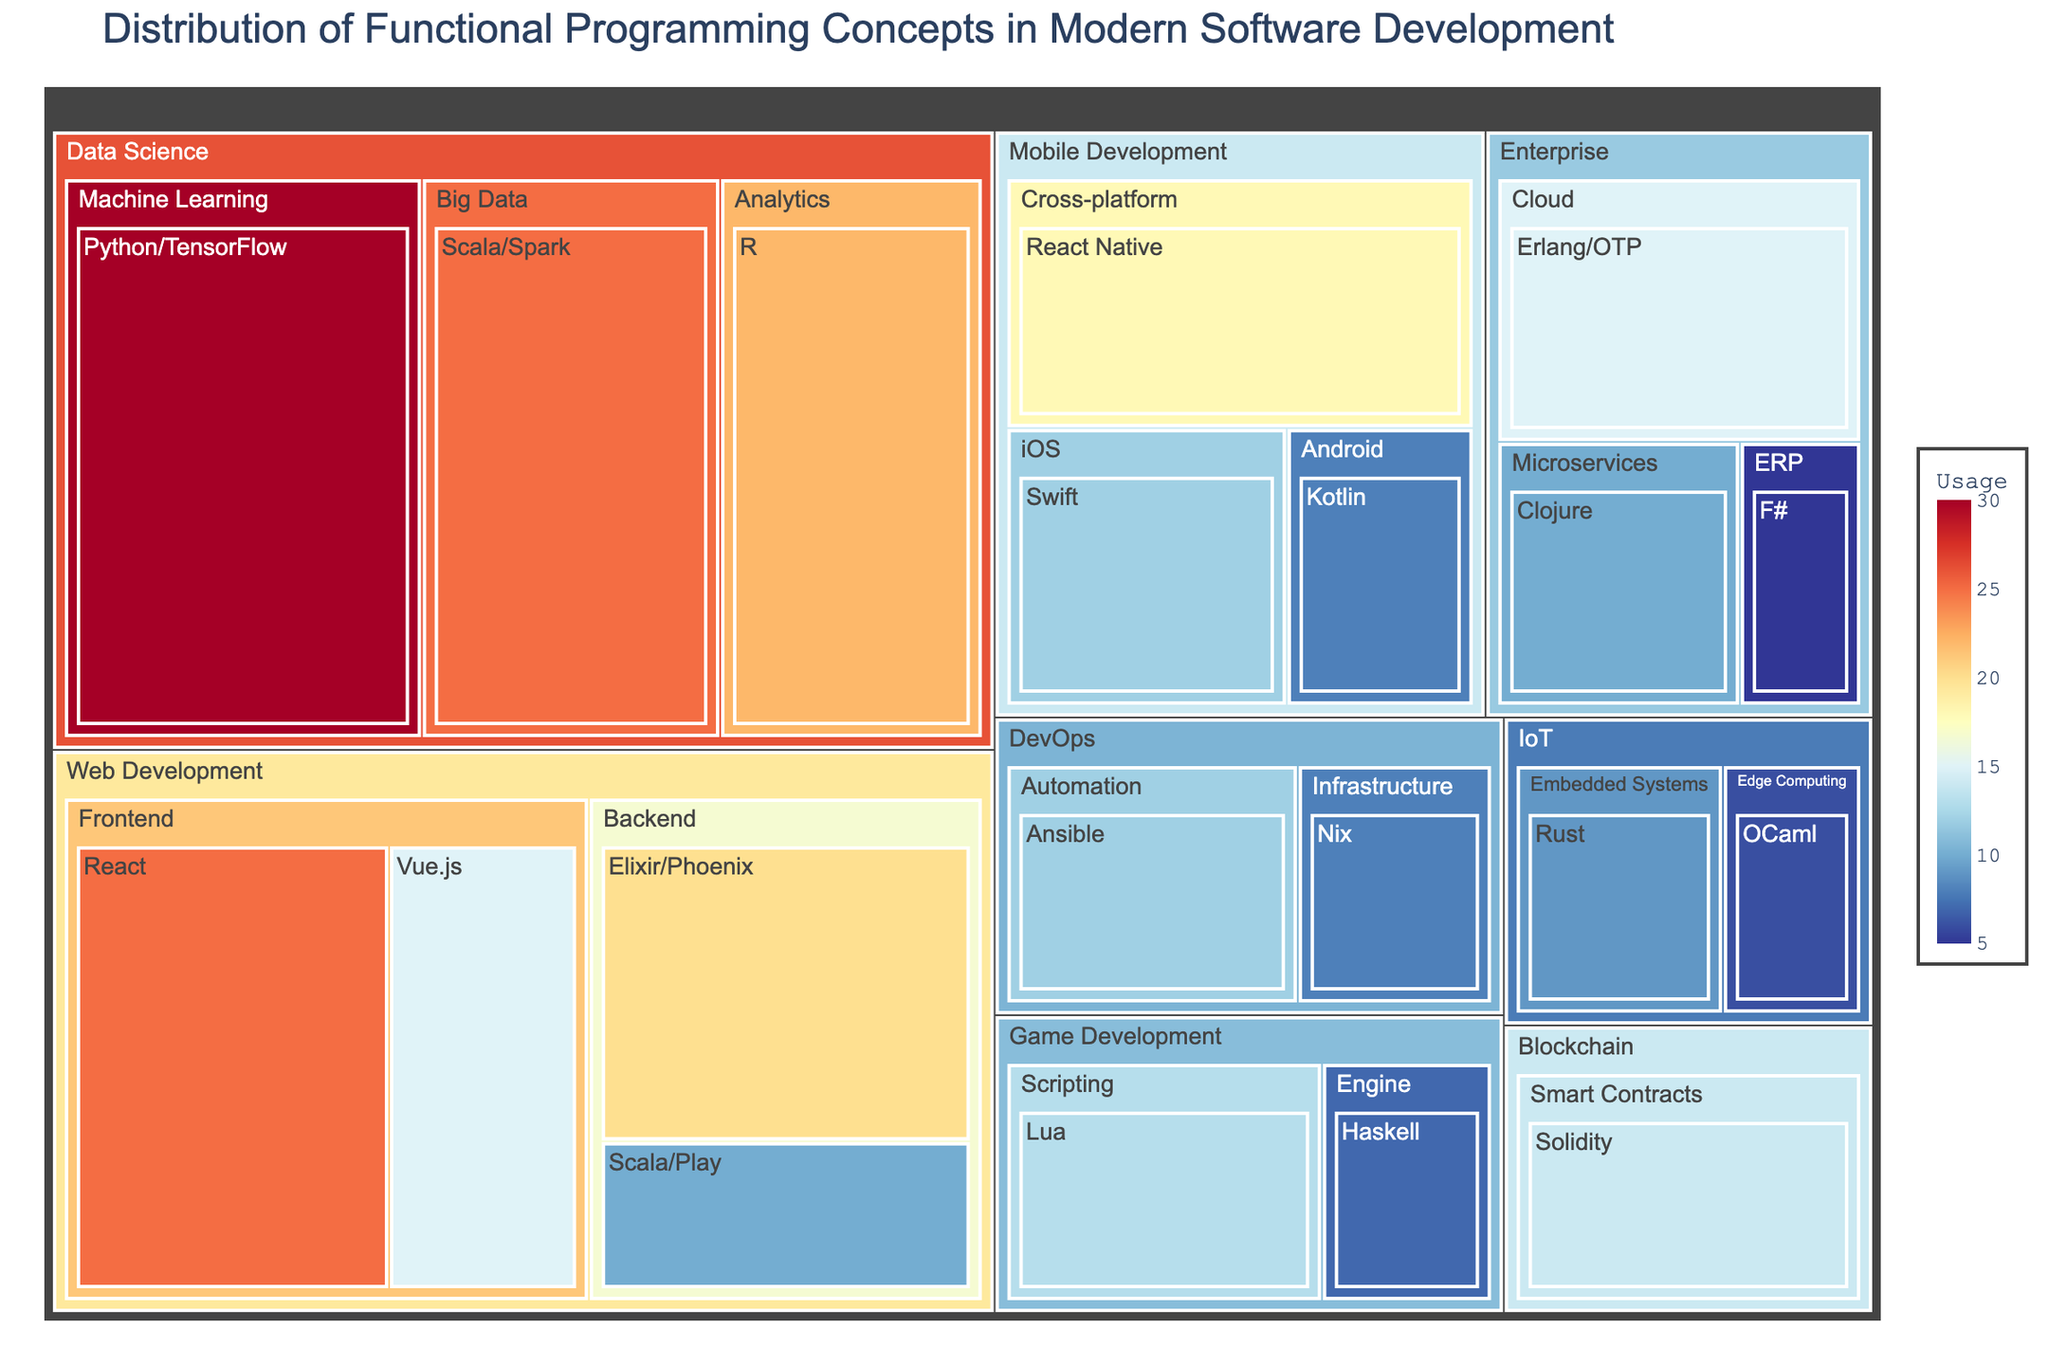Which industry has the highest usage of functional programming concepts? Look at the treemap and see which industry sector has the largest area. The size of areas represents the usage percentage.
Answer: Data Science What is the combined usage of functional programming concepts in Enterprise and IoT? Sum the usage values for all framework types within the Enterprise and IoT sectors from the treemap.
Answer: 45 Which concept is most used in Web Development (Backend)? Check the treemap for the Web Development (Backend) section and see which concept has the largest area.
Answer: Elixir/Phoenix How does the usage of React in Web Development (Frontend) compare to React Native in Mobile Development (Cross-platform)? Compare the usage values of React in Web Development (Frontend) and React Native in Mobile Development (Cross-platform) from the treemap.
Answer: React is more used What is the usage difference between Python/TensorFlow in Data Science (Machine Learning) and Swift in Mobile Development (iOS)? Subtract the usage value of Swift in Mobile Development (iOS) from Python/TensorFlow in Data Science (Machine Learning).
Answer: 18 Which functional programming concept is least used in Game Development? Check the treemap sections under Game Development and identify which concept has the smallest area.
Answer: Haskell What is the average usage of functional programming concepts within DevOps? Calculate the average by summing the usage values of all concepts within DevOps and dividing by the number of concepts. Usage values are 8 (Infrastructure) + 12 (Automation). The total is 20, and there are 2 concepts, so 20/2 = 10.
Answer: 10 Is the usage of Clojure in Enterprise (Microservices) greater than the usage of Lua in Game Development (Scripting)? Compare the usage values of Clojure in Enterprise (Microservices) and Lua in Game Development (Scripting) directly from the treemap.
Answer: No What is the total usage of functional programming concepts in industries related to development (Web, Mobile, Game)? Sum the usage values for all framework types within Web Development, Mobile Development, and Game Development from the treemap.
Answer: 133 Which industry category has the lowest representation of functional programming usage? Look at which industry sector has the smallest overall area in the treemap.
Answer: IoT 